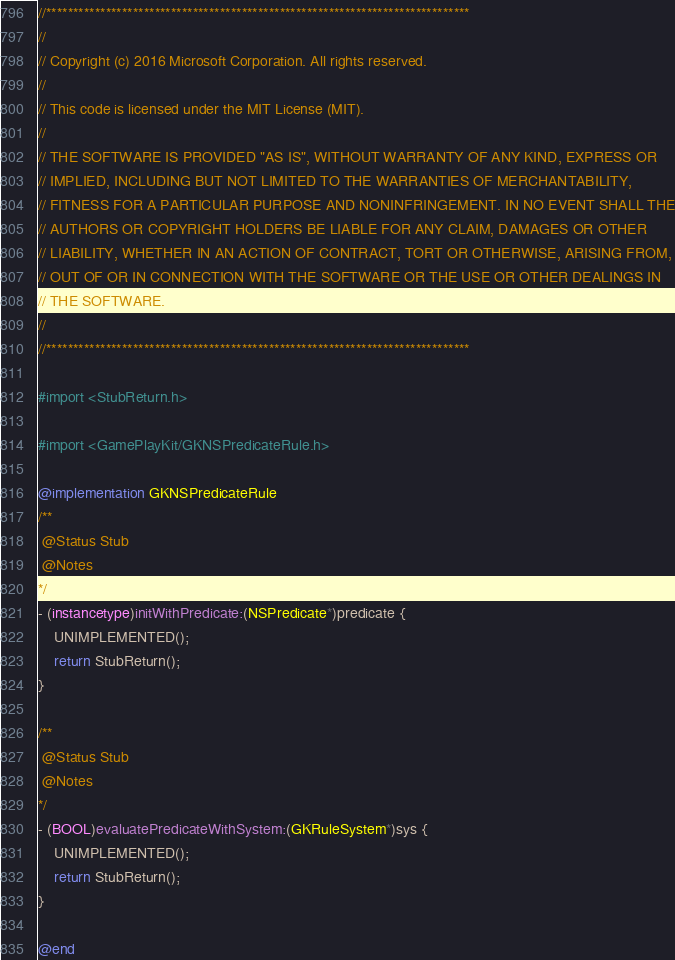<code> <loc_0><loc_0><loc_500><loc_500><_ObjectiveC_>//******************************************************************************
//
// Copyright (c) 2016 Microsoft Corporation. All rights reserved.
//
// This code is licensed under the MIT License (MIT).
//
// THE SOFTWARE IS PROVIDED "AS IS", WITHOUT WARRANTY OF ANY KIND, EXPRESS OR
// IMPLIED, INCLUDING BUT NOT LIMITED TO THE WARRANTIES OF MERCHANTABILITY,
// FITNESS FOR A PARTICULAR PURPOSE AND NONINFRINGEMENT. IN NO EVENT SHALL THE
// AUTHORS OR COPYRIGHT HOLDERS BE LIABLE FOR ANY CLAIM, DAMAGES OR OTHER
// LIABILITY, WHETHER IN AN ACTION OF CONTRACT, TORT OR OTHERWISE, ARISING FROM,
// OUT OF OR IN CONNECTION WITH THE SOFTWARE OR THE USE OR OTHER DEALINGS IN
// THE SOFTWARE.
//
//******************************************************************************

#import <StubReturn.h>

#import <GamePlayKit/GKNSPredicateRule.h>

@implementation GKNSPredicateRule
/**
 @Status Stub
 @Notes
*/
- (instancetype)initWithPredicate:(NSPredicate*)predicate {
    UNIMPLEMENTED();
    return StubReturn();
}

/**
 @Status Stub
 @Notes
*/
- (BOOL)evaluatePredicateWithSystem:(GKRuleSystem*)sys {
    UNIMPLEMENTED();
    return StubReturn();
}

@end
</code> 